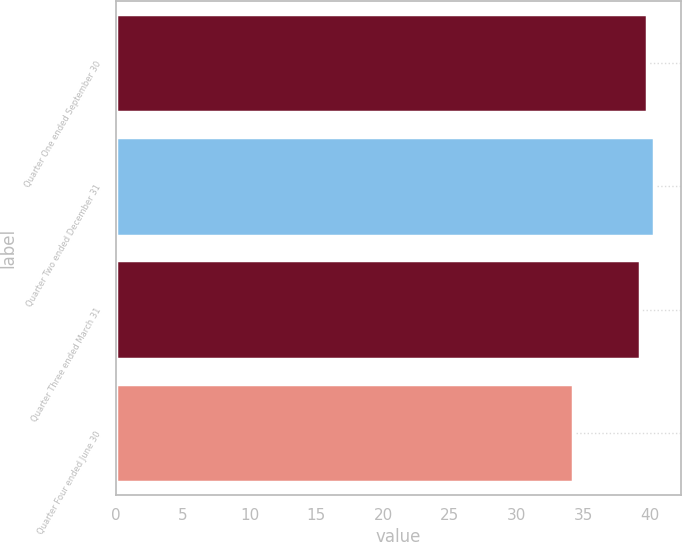Convert chart. <chart><loc_0><loc_0><loc_500><loc_500><bar_chart><fcel>Quarter One ended September 30<fcel>Quarter Two ended December 31<fcel>Quarter Three ended March 31<fcel>Quarter Four ended June 30<nl><fcel>39.75<fcel>40.3<fcel>39.2<fcel>34.19<nl></chart> 